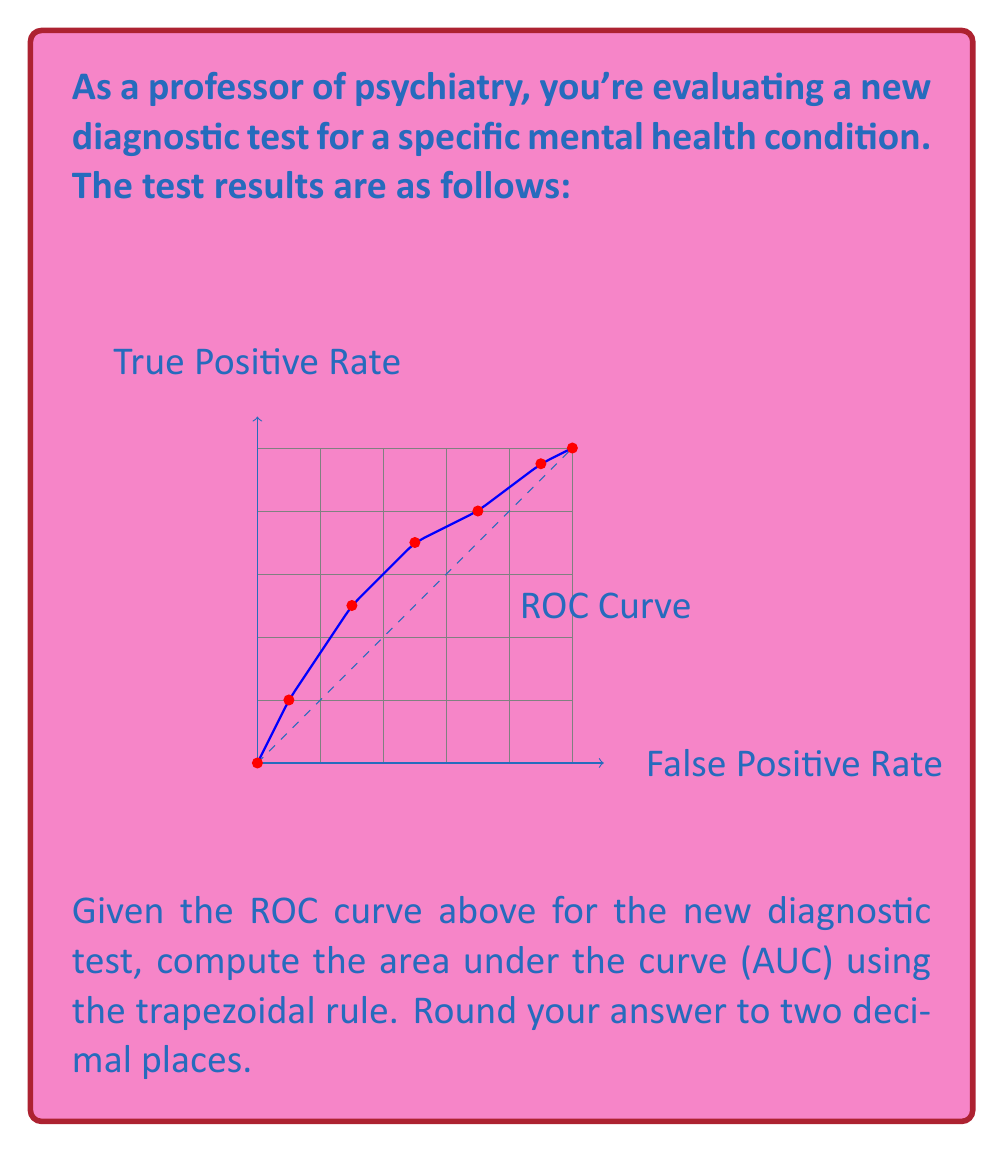Show me your answer to this math problem. To compute the area under the ROC curve using the trapezoidal rule:

1) We have the following points on the curve:
   (0,0), (0.1,0.2), (0.3,0.5), (0.5,0.7), (0.7,0.8), (0.9,0.95), (1,1)

2) The trapezoidal rule formula for n trapezoids is:

   $$AUC \approx \sum_{i=1}^{n} \frac{1}{2}(x_i - x_{i-1})(y_i + y_{i-1})$$

3) Let's calculate each trapezoid:

   $\frac{1}{2}(0.1-0)(0.2+0) = 0.01$
   $\frac{1}{2}(0.3-0.1)(0.5+0.2) = 0.07$
   $\frac{1}{2}(0.5-0.3)(0.7+0.5) = 0.12$
   $\frac{1}{2}(0.7-0.5)(0.8+0.7) = 0.15$
   $\frac{1}{2}(0.9-0.7)(0.95+0.8) = 0.175$
   $\frac{1}{2}(1-0.9)(1+0.95) = 0.0975$

4) Sum all trapezoid areas:

   $0.01 + 0.07 + 0.12 + 0.15 + 0.175 + 0.0975 = 0.6225$

5) Rounding to two decimal places:

   $0.6225 \approx 0.62$

Therefore, the area under the ROC curve is approximately 0.62.
Answer: 0.62 